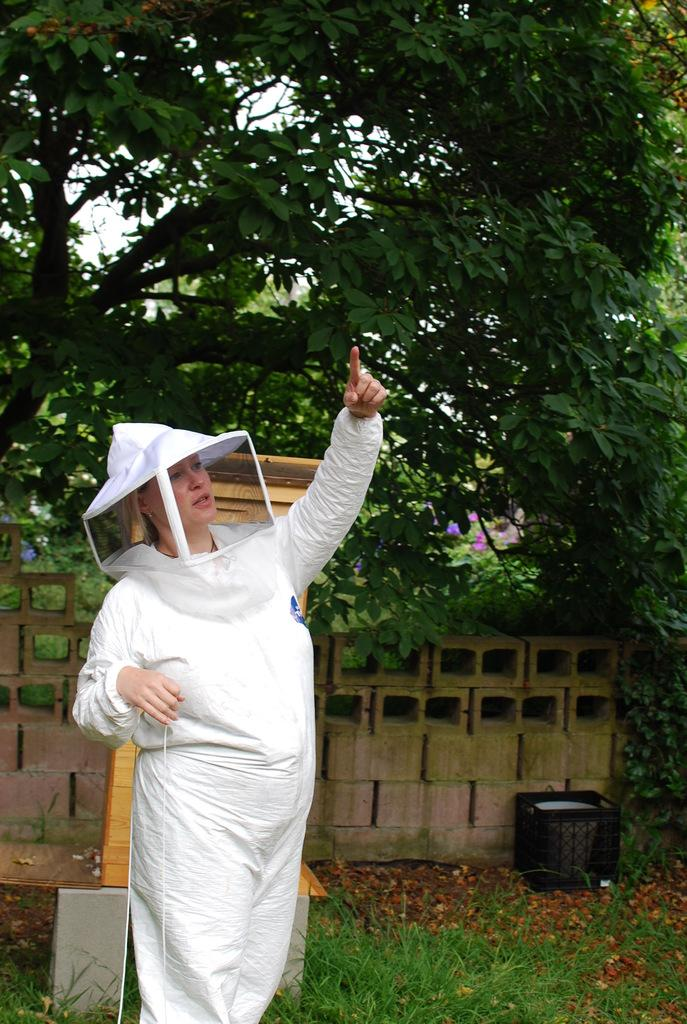What is the woman in the image standing on? The woman is standing on the grass. What object can be seen in the image besides the woman? There is a bin in the image. What can be seen in the background of the image? There are trees and the sky visible in the background of the image. What type of soup is the woman holding in the image? There is no soup present in the image; the woman is standing on the grass and there is a bin nearby. 